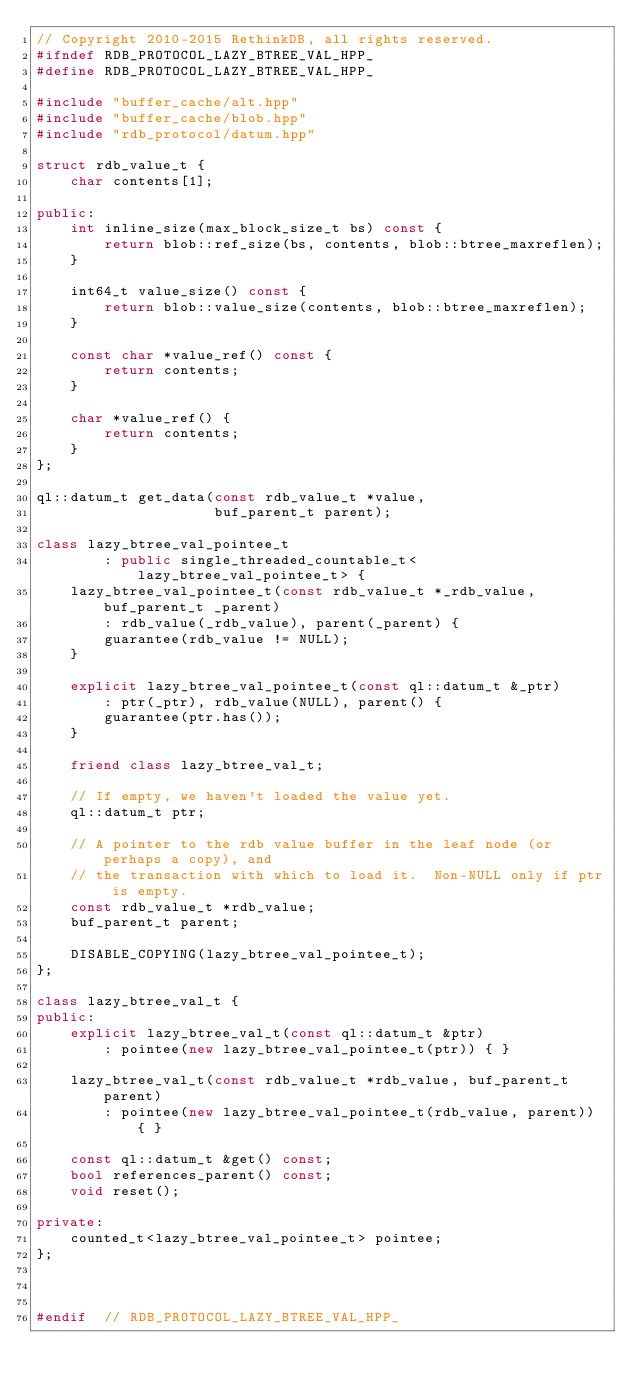Convert code to text. <code><loc_0><loc_0><loc_500><loc_500><_C++_>// Copyright 2010-2015 RethinkDB, all rights reserved.
#ifndef RDB_PROTOCOL_LAZY_BTREE_VAL_HPP_
#define RDB_PROTOCOL_LAZY_BTREE_VAL_HPP_

#include "buffer_cache/alt.hpp"
#include "buffer_cache/blob.hpp"
#include "rdb_protocol/datum.hpp"

struct rdb_value_t {
    char contents[1];

public:
    int inline_size(max_block_size_t bs) const {
        return blob::ref_size(bs, contents, blob::btree_maxreflen);
    }

    int64_t value_size() const {
        return blob::value_size(contents, blob::btree_maxreflen);
    }

    const char *value_ref() const {
        return contents;
    }

    char *value_ref() {
        return contents;
    }
};

ql::datum_t get_data(const rdb_value_t *value,
                     buf_parent_t parent);

class lazy_btree_val_pointee_t
        : public single_threaded_countable_t<lazy_btree_val_pointee_t> {
    lazy_btree_val_pointee_t(const rdb_value_t *_rdb_value, buf_parent_t _parent)
        : rdb_value(_rdb_value), parent(_parent) {
        guarantee(rdb_value != NULL);
    }

    explicit lazy_btree_val_pointee_t(const ql::datum_t &_ptr)
        : ptr(_ptr), rdb_value(NULL), parent() {
        guarantee(ptr.has());
    }

    friend class lazy_btree_val_t;

    // If empty, we haven't loaded the value yet.
    ql::datum_t ptr;

    // A pointer to the rdb value buffer in the leaf node (or perhaps a copy), and
    // the transaction with which to load it.  Non-NULL only if ptr is empty.
    const rdb_value_t *rdb_value;
    buf_parent_t parent;

    DISABLE_COPYING(lazy_btree_val_pointee_t);
};

class lazy_btree_val_t {
public:
    explicit lazy_btree_val_t(const ql::datum_t &ptr)
        : pointee(new lazy_btree_val_pointee_t(ptr)) { }

    lazy_btree_val_t(const rdb_value_t *rdb_value, buf_parent_t parent)
        : pointee(new lazy_btree_val_pointee_t(rdb_value, parent)) { }

    const ql::datum_t &get() const;
    bool references_parent() const;
    void reset();

private:
    counted_t<lazy_btree_val_pointee_t> pointee;
};



#endif  // RDB_PROTOCOL_LAZY_BTREE_VAL_HPP_
</code> 